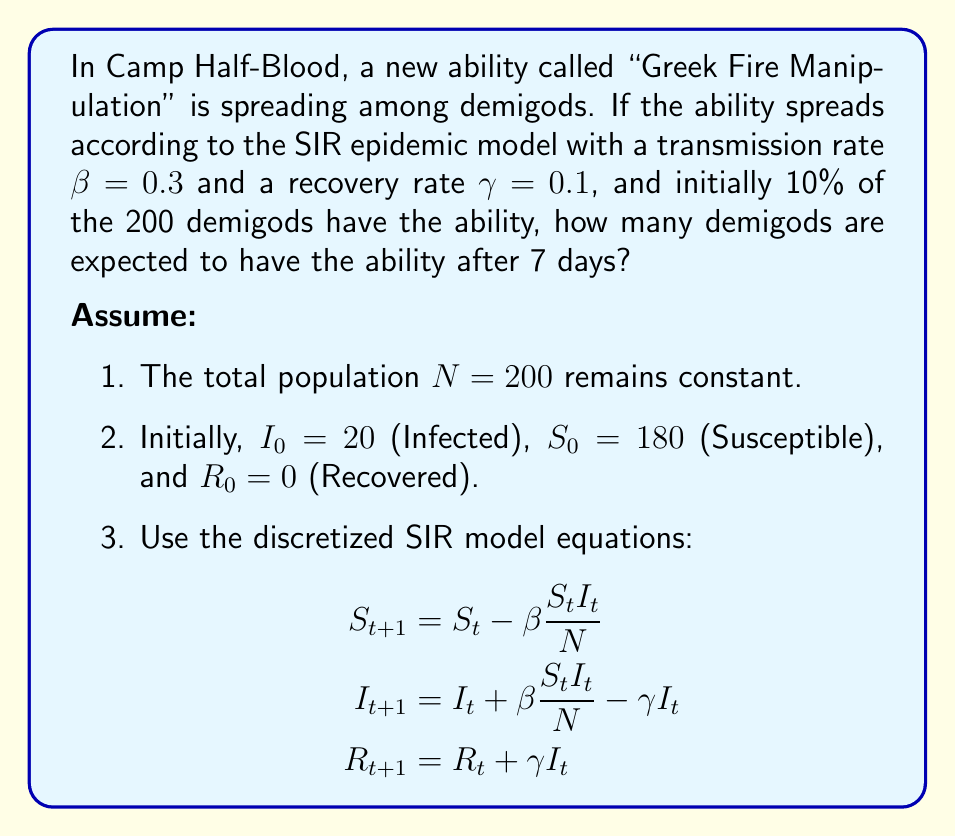Can you solve this math problem? To solve this problem, we'll use the discretized SIR model equations and iterate through 7 days:

1. Initialize variables:
   $N = 200$, $S_0 = 180$, $I_0 = 20$, $R_0 = 0$, $\beta = 0.3$, $\gamma = 0.1$

2. Calculate for each day (t = 0 to 6):
   $$S_{t+1} = S_t - 0.3 \frac{S_t I_t}{200}$$
   $$I_{t+1} = I_t + 0.3 \frac{S_t I_t}{200} - 0.1 I_t$$
   $$R_{t+1} = R_t + 0.1 I_t$$

3. Iterate:
   Day 0: $S_0 = 180$, $I_0 = 20$, $R_0 = 0$
   Day 1: $S_1 = 174.6$, $I_1 = 23.4$, $R_1 = 2.0$
   Day 2: $S_2 = 168.5$, $I_2 = 27.1$, $R_2 = 4.4$
   Day 3: $S_3 = 161.8$, $I_3 = 31.0$, $R_3 = 7.2$
   Day 4: $S_4 = 154.5$, $I_4 = 35.0$, $R_4 = 10.5$
   Day 5: $S_5 = 146.8$, $I_5 = 39.0$, $R_5 = 14.2$
   Day 6: $S_6 = 138.7$, $I_6 = 42.9$, $R_6 = 18.4$
   Day 7: $S_7 = 130.4$, $I_7 = 46.6$, $R_7 = 23.0$

4. The number of demigods with the ability after 7 days is $I_7$, rounded to the nearest whole number.
Answer: 47 demigods 